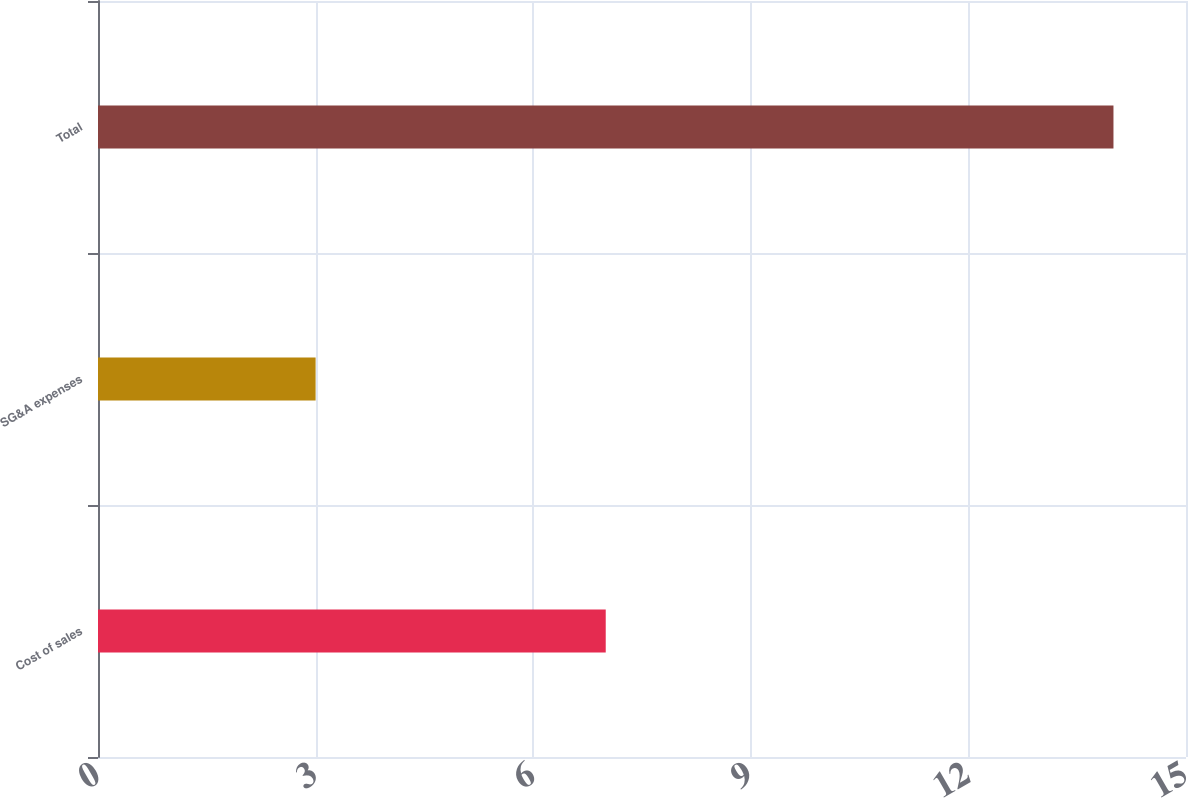<chart> <loc_0><loc_0><loc_500><loc_500><bar_chart><fcel>Cost of sales<fcel>SG&A expenses<fcel>Total<nl><fcel>7<fcel>3<fcel>14<nl></chart> 